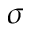Convert formula to latex. <formula><loc_0><loc_0><loc_500><loc_500>\sigma</formula> 